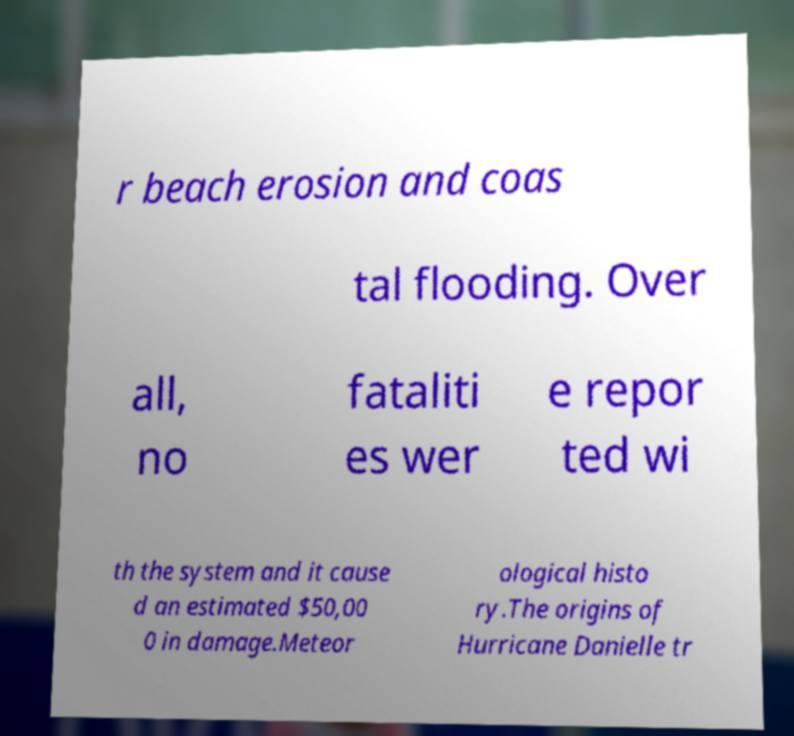There's text embedded in this image that I need extracted. Can you transcribe it verbatim? r beach erosion and coas tal flooding. Over all, no fataliti es wer e repor ted wi th the system and it cause d an estimated $50,00 0 in damage.Meteor ological histo ry.The origins of Hurricane Danielle tr 